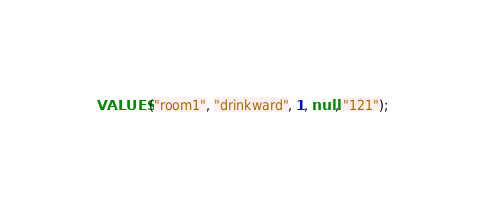<code> <loc_0><loc_0><loc_500><loc_500><_SQL_>VALUES ("room1", "drinkward", 1, null, "121");</code> 